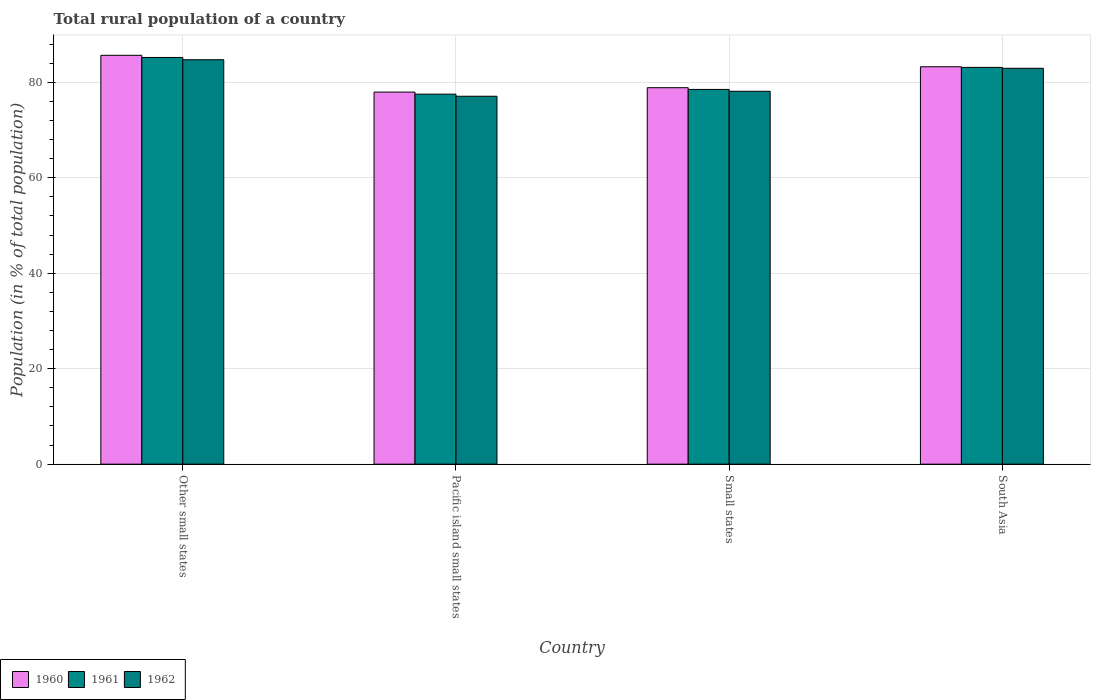How many different coloured bars are there?
Keep it short and to the point. 3. How many groups of bars are there?
Provide a succinct answer. 4. How many bars are there on the 4th tick from the left?
Provide a short and direct response. 3. What is the label of the 4th group of bars from the left?
Your answer should be very brief. South Asia. What is the rural population in 1961 in South Asia?
Your answer should be compact. 83.13. Across all countries, what is the maximum rural population in 1962?
Make the answer very short. 84.74. Across all countries, what is the minimum rural population in 1962?
Make the answer very short. 77.09. In which country was the rural population in 1961 maximum?
Your answer should be compact. Other small states. In which country was the rural population in 1961 minimum?
Offer a terse response. Pacific island small states. What is the total rural population in 1961 in the graph?
Keep it short and to the point. 324.39. What is the difference between the rural population in 1960 in Pacific island small states and that in Small states?
Give a very brief answer. -0.92. What is the difference between the rural population in 1962 in Other small states and the rural population in 1961 in Small states?
Offer a very short reply. 6.22. What is the average rural population in 1960 per country?
Provide a succinct answer. 81.44. What is the difference between the rural population of/in 1961 and rural population of/in 1960 in South Asia?
Give a very brief answer. -0.13. In how many countries, is the rural population in 1960 greater than 52 %?
Ensure brevity in your answer.  4. What is the ratio of the rural population in 1961 in Other small states to that in South Asia?
Give a very brief answer. 1.03. Is the rural population in 1961 in Pacific island small states less than that in South Asia?
Your answer should be compact. Yes. Is the difference between the rural population in 1961 in Pacific island small states and Small states greater than the difference between the rural population in 1960 in Pacific island small states and Small states?
Make the answer very short. No. What is the difference between the highest and the second highest rural population in 1961?
Make the answer very short. -2.08. What is the difference between the highest and the lowest rural population in 1962?
Your answer should be compact. 7.65. Is it the case that in every country, the sum of the rural population in 1960 and rural population in 1961 is greater than the rural population in 1962?
Your answer should be compact. Yes. How many bars are there?
Provide a short and direct response. 12. Are all the bars in the graph horizontal?
Your answer should be very brief. No. How many countries are there in the graph?
Your answer should be compact. 4. Does the graph contain grids?
Your response must be concise. Yes. Where does the legend appear in the graph?
Offer a terse response. Bottom left. How many legend labels are there?
Provide a succinct answer. 3. How are the legend labels stacked?
Your answer should be very brief. Horizontal. What is the title of the graph?
Your response must be concise. Total rural population of a country. Does "1974" appear as one of the legend labels in the graph?
Your answer should be compact. No. What is the label or title of the Y-axis?
Offer a terse response. Population (in % of total population). What is the Population (in % of total population) of 1960 in Other small states?
Keep it short and to the point. 85.66. What is the Population (in % of total population) of 1961 in Other small states?
Give a very brief answer. 85.21. What is the Population (in % of total population) in 1962 in Other small states?
Offer a very short reply. 84.74. What is the Population (in % of total population) in 1960 in Pacific island small states?
Your response must be concise. 77.96. What is the Population (in % of total population) of 1961 in Pacific island small states?
Offer a very short reply. 77.53. What is the Population (in % of total population) in 1962 in Pacific island small states?
Provide a succinct answer. 77.09. What is the Population (in % of total population) of 1960 in Small states?
Offer a terse response. 78.88. What is the Population (in % of total population) of 1961 in Small states?
Offer a very short reply. 78.52. What is the Population (in % of total population) of 1962 in Small states?
Offer a terse response. 78.13. What is the Population (in % of total population) of 1960 in South Asia?
Your response must be concise. 83.26. What is the Population (in % of total population) in 1961 in South Asia?
Offer a terse response. 83.13. What is the Population (in % of total population) in 1962 in South Asia?
Ensure brevity in your answer.  82.95. Across all countries, what is the maximum Population (in % of total population) of 1960?
Ensure brevity in your answer.  85.66. Across all countries, what is the maximum Population (in % of total population) of 1961?
Offer a terse response. 85.21. Across all countries, what is the maximum Population (in % of total population) in 1962?
Your answer should be very brief. 84.74. Across all countries, what is the minimum Population (in % of total population) of 1960?
Make the answer very short. 77.96. Across all countries, what is the minimum Population (in % of total population) of 1961?
Provide a short and direct response. 77.53. Across all countries, what is the minimum Population (in % of total population) in 1962?
Keep it short and to the point. 77.09. What is the total Population (in % of total population) in 1960 in the graph?
Ensure brevity in your answer.  325.76. What is the total Population (in % of total population) in 1961 in the graph?
Make the answer very short. 324.39. What is the total Population (in % of total population) in 1962 in the graph?
Provide a succinct answer. 322.9. What is the difference between the Population (in % of total population) in 1960 in Other small states and that in Pacific island small states?
Offer a terse response. 7.71. What is the difference between the Population (in % of total population) in 1961 in Other small states and that in Pacific island small states?
Offer a terse response. 7.69. What is the difference between the Population (in % of total population) of 1962 in Other small states and that in Pacific island small states?
Make the answer very short. 7.65. What is the difference between the Population (in % of total population) of 1960 in Other small states and that in Small states?
Provide a short and direct response. 6.78. What is the difference between the Population (in % of total population) of 1961 in Other small states and that in Small states?
Give a very brief answer. 6.7. What is the difference between the Population (in % of total population) in 1962 in Other small states and that in Small states?
Provide a short and direct response. 6.61. What is the difference between the Population (in % of total population) in 1960 in Other small states and that in South Asia?
Your response must be concise. 2.4. What is the difference between the Population (in % of total population) of 1961 in Other small states and that in South Asia?
Keep it short and to the point. 2.08. What is the difference between the Population (in % of total population) in 1962 in Other small states and that in South Asia?
Your answer should be very brief. 1.79. What is the difference between the Population (in % of total population) in 1960 in Pacific island small states and that in Small states?
Provide a succinct answer. -0.92. What is the difference between the Population (in % of total population) of 1961 in Pacific island small states and that in Small states?
Ensure brevity in your answer.  -0.99. What is the difference between the Population (in % of total population) in 1962 in Pacific island small states and that in Small states?
Offer a very short reply. -1.04. What is the difference between the Population (in % of total population) in 1960 in Pacific island small states and that in South Asia?
Provide a short and direct response. -5.31. What is the difference between the Population (in % of total population) of 1961 in Pacific island small states and that in South Asia?
Offer a terse response. -5.61. What is the difference between the Population (in % of total population) of 1962 in Pacific island small states and that in South Asia?
Offer a very short reply. -5.86. What is the difference between the Population (in % of total population) in 1960 in Small states and that in South Asia?
Ensure brevity in your answer.  -4.38. What is the difference between the Population (in % of total population) of 1961 in Small states and that in South Asia?
Offer a very short reply. -4.62. What is the difference between the Population (in % of total population) in 1962 in Small states and that in South Asia?
Offer a terse response. -4.82. What is the difference between the Population (in % of total population) of 1960 in Other small states and the Population (in % of total population) of 1961 in Pacific island small states?
Give a very brief answer. 8.14. What is the difference between the Population (in % of total population) of 1960 in Other small states and the Population (in % of total population) of 1962 in Pacific island small states?
Ensure brevity in your answer.  8.58. What is the difference between the Population (in % of total population) in 1961 in Other small states and the Population (in % of total population) in 1962 in Pacific island small states?
Provide a short and direct response. 8.13. What is the difference between the Population (in % of total population) in 1960 in Other small states and the Population (in % of total population) in 1961 in Small states?
Your response must be concise. 7.15. What is the difference between the Population (in % of total population) of 1960 in Other small states and the Population (in % of total population) of 1962 in Small states?
Keep it short and to the point. 7.53. What is the difference between the Population (in % of total population) of 1961 in Other small states and the Population (in % of total population) of 1962 in Small states?
Keep it short and to the point. 7.09. What is the difference between the Population (in % of total population) of 1960 in Other small states and the Population (in % of total population) of 1961 in South Asia?
Ensure brevity in your answer.  2.53. What is the difference between the Population (in % of total population) in 1960 in Other small states and the Population (in % of total population) in 1962 in South Asia?
Your answer should be very brief. 2.72. What is the difference between the Population (in % of total population) of 1961 in Other small states and the Population (in % of total population) of 1962 in South Asia?
Your answer should be very brief. 2.27. What is the difference between the Population (in % of total population) of 1960 in Pacific island small states and the Population (in % of total population) of 1961 in Small states?
Your response must be concise. -0.56. What is the difference between the Population (in % of total population) of 1960 in Pacific island small states and the Population (in % of total population) of 1962 in Small states?
Give a very brief answer. -0.17. What is the difference between the Population (in % of total population) of 1961 in Pacific island small states and the Population (in % of total population) of 1962 in Small states?
Offer a very short reply. -0.6. What is the difference between the Population (in % of total population) of 1960 in Pacific island small states and the Population (in % of total population) of 1961 in South Asia?
Give a very brief answer. -5.18. What is the difference between the Population (in % of total population) of 1960 in Pacific island small states and the Population (in % of total population) of 1962 in South Asia?
Keep it short and to the point. -4.99. What is the difference between the Population (in % of total population) in 1961 in Pacific island small states and the Population (in % of total population) in 1962 in South Asia?
Keep it short and to the point. -5.42. What is the difference between the Population (in % of total population) of 1960 in Small states and the Population (in % of total population) of 1961 in South Asia?
Give a very brief answer. -4.25. What is the difference between the Population (in % of total population) of 1960 in Small states and the Population (in % of total population) of 1962 in South Asia?
Your answer should be very brief. -4.07. What is the difference between the Population (in % of total population) in 1961 in Small states and the Population (in % of total population) in 1962 in South Asia?
Ensure brevity in your answer.  -4.43. What is the average Population (in % of total population) in 1960 per country?
Make the answer very short. 81.44. What is the average Population (in % of total population) of 1961 per country?
Offer a terse response. 81.1. What is the average Population (in % of total population) of 1962 per country?
Provide a short and direct response. 80.73. What is the difference between the Population (in % of total population) in 1960 and Population (in % of total population) in 1961 in Other small states?
Offer a terse response. 0.45. What is the difference between the Population (in % of total population) in 1960 and Population (in % of total population) in 1962 in Other small states?
Ensure brevity in your answer.  0.92. What is the difference between the Population (in % of total population) in 1961 and Population (in % of total population) in 1962 in Other small states?
Your answer should be very brief. 0.47. What is the difference between the Population (in % of total population) of 1960 and Population (in % of total population) of 1961 in Pacific island small states?
Offer a very short reply. 0.43. What is the difference between the Population (in % of total population) in 1960 and Population (in % of total population) in 1962 in Pacific island small states?
Provide a succinct answer. 0.87. What is the difference between the Population (in % of total population) in 1961 and Population (in % of total population) in 1962 in Pacific island small states?
Your answer should be compact. 0.44. What is the difference between the Population (in % of total population) in 1960 and Population (in % of total population) in 1961 in Small states?
Provide a short and direct response. 0.36. What is the difference between the Population (in % of total population) of 1960 and Population (in % of total population) of 1962 in Small states?
Provide a succinct answer. 0.75. What is the difference between the Population (in % of total population) in 1961 and Population (in % of total population) in 1962 in Small states?
Ensure brevity in your answer.  0.39. What is the difference between the Population (in % of total population) of 1960 and Population (in % of total population) of 1961 in South Asia?
Keep it short and to the point. 0.13. What is the difference between the Population (in % of total population) of 1960 and Population (in % of total population) of 1962 in South Asia?
Make the answer very short. 0.32. What is the difference between the Population (in % of total population) of 1961 and Population (in % of total population) of 1962 in South Asia?
Keep it short and to the point. 0.19. What is the ratio of the Population (in % of total population) in 1960 in Other small states to that in Pacific island small states?
Provide a short and direct response. 1.1. What is the ratio of the Population (in % of total population) in 1961 in Other small states to that in Pacific island small states?
Your answer should be very brief. 1.1. What is the ratio of the Population (in % of total population) in 1962 in Other small states to that in Pacific island small states?
Keep it short and to the point. 1.1. What is the ratio of the Population (in % of total population) of 1960 in Other small states to that in Small states?
Provide a short and direct response. 1.09. What is the ratio of the Population (in % of total population) in 1961 in Other small states to that in Small states?
Your answer should be very brief. 1.09. What is the ratio of the Population (in % of total population) in 1962 in Other small states to that in Small states?
Give a very brief answer. 1.08. What is the ratio of the Population (in % of total population) in 1960 in Other small states to that in South Asia?
Your response must be concise. 1.03. What is the ratio of the Population (in % of total population) of 1961 in Other small states to that in South Asia?
Give a very brief answer. 1.02. What is the ratio of the Population (in % of total population) in 1962 in Other small states to that in South Asia?
Give a very brief answer. 1.02. What is the ratio of the Population (in % of total population) of 1960 in Pacific island small states to that in Small states?
Keep it short and to the point. 0.99. What is the ratio of the Population (in % of total population) of 1961 in Pacific island small states to that in Small states?
Keep it short and to the point. 0.99. What is the ratio of the Population (in % of total population) in 1962 in Pacific island small states to that in Small states?
Your response must be concise. 0.99. What is the ratio of the Population (in % of total population) in 1960 in Pacific island small states to that in South Asia?
Make the answer very short. 0.94. What is the ratio of the Population (in % of total population) in 1961 in Pacific island small states to that in South Asia?
Your answer should be compact. 0.93. What is the ratio of the Population (in % of total population) in 1962 in Pacific island small states to that in South Asia?
Offer a very short reply. 0.93. What is the ratio of the Population (in % of total population) of 1960 in Small states to that in South Asia?
Your answer should be compact. 0.95. What is the ratio of the Population (in % of total population) in 1961 in Small states to that in South Asia?
Offer a very short reply. 0.94. What is the ratio of the Population (in % of total population) of 1962 in Small states to that in South Asia?
Provide a succinct answer. 0.94. What is the difference between the highest and the second highest Population (in % of total population) in 1960?
Make the answer very short. 2.4. What is the difference between the highest and the second highest Population (in % of total population) in 1961?
Your response must be concise. 2.08. What is the difference between the highest and the second highest Population (in % of total population) of 1962?
Your answer should be compact. 1.79. What is the difference between the highest and the lowest Population (in % of total population) in 1960?
Give a very brief answer. 7.71. What is the difference between the highest and the lowest Population (in % of total population) in 1961?
Offer a very short reply. 7.69. What is the difference between the highest and the lowest Population (in % of total population) of 1962?
Give a very brief answer. 7.65. 